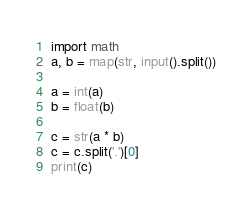<code> <loc_0><loc_0><loc_500><loc_500><_Python_>import math
a, b = map(str, input().split())

a = int(a)
b = float(b)

c = str(a * b)
c = c.split('.')[0]
print(c)</code> 